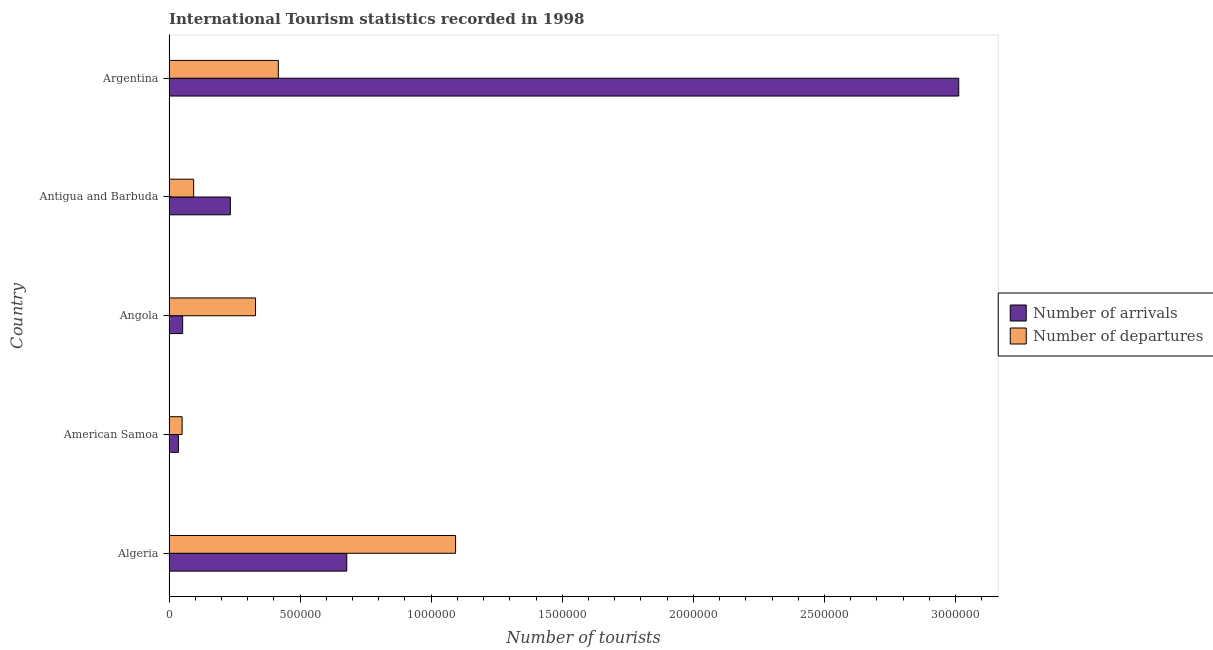How many groups of bars are there?
Offer a very short reply. 5. How many bars are there on the 4th tick from the top?
Offer a very short reply. 2. What is the label of the 4th group of bars from the top?
Provide a succinct answer. American Samoa. What is the number of tourist arrivals in Algeria?
Make the answer very short. 6.78e+05. Across all countries, what is the maximum number of tourist departures?
Your response must be concise. 1.09e+06. Across all countries, what is the minimum number of tourist arrivals?
Ensure brevity in your answer.  3.60e+04. In which country was the number of tourist departures maximum?
Your response must be concise. Algeria. In which country was the number of tourist departures minimum?
Your answer should be compact. American Samoa. What is the total number of tourist arrivals in the graph?
Ensure brevity in your answer.  4.01e+06. What is the difference between the number of tourist arrivals in American Samoa and that in Angola?
Provide a succinct answer. -1.60e+04. What is the difference between the number of tourist departures in Antigua and Barbuda and the number of tourist arrivals in Algeria?
Provide a succinct answer. -5.84e+05. What is the average number of tourist departures per country?
Ensure brevity in your answer.  3.97e+05. What is the difference between the number of tourist arrivals and number of tourist departures in Argentina?
Your answer should be very brief. 2.60e+06. In how many countries, is the number of tourist arrivals greater than 100000 ?
Provide a short and direct response. 3. What is the ratio of the number of tourist departures in Angola to that in Antigua and Barbuda?
Offer a very short reply. 3.51. Is the difference between the number of tourist arrivals in Algeria and American Samoa greater than the difference between the number of tourist departures in Algeria and American Samoa?
Provide a succinct answer. No. What is the difference between the highest and the second highest number of tourist departures?
Make the answer very short. 6.76e+05. What is the difference between the highest and the lowest number of tourist arrivals?
Give a very brief answer. 2.98e+06. What does the 2nd bar from the top in Argentina represents?
Ensure brevity in your answer.  Number of arrivals. What does the 1st bar from the bottom in Argentina represents?
Offer a terse response. Number of arrivals. How many bars are there?
Your response must be concise. 10. What is the difference between two consecutive major ticks on the X-axis?
Your response must be concise. 5.00e+05. Does the graph contain any zero values?
Keep it short and to the point. No. What is the title of the graph?
Give a very brief answer. International Tourism statistics recorded in 1998. Does "Secondary" appear as one of the legend labels in the graph?
Your response must be concise. No. What is the label or title of the X-axis?
Provide a short and direct response. Number of tourists. What is the label or title of the Y-axis?
Your response must be concise. Country. What is the Number of tourists of Number of arrivals in Algeria?
Provide a succinct answer. 6.78e+05. What is the Number of tourists in Number of departures in Algeria?
Offer a very short reply. 1.09e+06. What is the Number of tourists in Number of arrivals in American Samoa?
Your answer should be compact. 3.60e+04. What is the Number of tourists of Number of departures in American Samoa?
Ensure brevity in your answer.  5.00e+04. What is the Number of tourists of Number of arrivals in Angola?
Keep it short and to the point. 5.20e+04. What is the Number of tourists in Number of arrivals in Antigua and Barbuda?
Offer a very short reply. 2.34e+05. What is the Number of tourists in Number of departures in Antigua and Barbuda?
Provide a short and direct response. 9.40e+04. What is the Number of tourists in Number of arrivals in Argentina?
Make the answer very short. 3.01e+06. What is the Number of tourists in Number of departures in Argentina?
Your response must be concise. 4.17e+05. Across all countries, what is the maximum Number of tourists of Number of arrivals?
Provide a succinct answer. 3.01e+06. Across all countries, what is the maximum Number of tourists of Number of departures?
Offer a very short reply. 1.09e+06. Across all countries, what is the minimum Number of tourists of Number of arrivals?
Give a very brief answer. 3.60e+04. What is the total Number of tourists in Number of arrivals in the graph?
Provide a succinct answer. 4.01e+06. What is the total Number of tourists of Number of departures in the graph?
Offer a very short reply. 1.98e+06. What is the difference between the Number of tourists of Number of arrivals in Algeria and that in American Samoa?
Your answer should be very brief. 6.42e+05. What is the difference between the Number of tourists in Number of departures in Algeria and that in American Samoa?
Your answer should be very brief. 1.04e+06. What is the difference between the Number of tourists in Number of arrivals in Algeria and that in Angola?
Make the answer very short. 6.26e+05. What is the difference between the Number of tourists of Number of departures in Algeria and that in Angola?
Keep it short and to the point. 7.63e+05. What is the difference between the Number of tourists in Number of arrivals in Algeria and that in Antigua and Barbuda?
Make the answer very short. 4.44e+05. What is the difference between the Number of tourists in Number of departures in Algeria and that in Antigua and Barbuda?
Offer a terse response. 9.99e+05. What is the difference between the Number of tourists in Number of arrivals in Algeria and that in Argentina?
Your answer should be compact. -2.33e+06. What is the difference between the Number of tourists in Number of departures in Algeria and that in Argentina?
Ensure brevity in your answer.  6.76e+05. What is the difference between the Number of tourists of Number of arrivals in American Samoa and that in Angola?
Your answer should be compact. -1.60e+04. What is the difference between the Number of tourists of Number of departures in American Samoa and that in Angola?
Your answer should be very brief. -2.80e+05. What is the difference between the Number of tourists of Number of arrivals in American Samoa and that in Antigua and Barbuda?
Keep it short and to the point. -1.98e+05. What is the difference between the Number of tourists of Number of departures in American Samoa and that in Antigua and Barbuda?
Make the answer very short. -4.40e+04. What is the difference between the Number of tourists of Number of arrivals in American Samoa and that in Argentina?
Ensure brevity in your answer.  -2.98e+06. What is the difference between the Number of tourists of Number of departures in American Samoa and that in Argentina?
Provide a short and direct response. -3.67e+05. What is the difference between the Number of tourists of Number of arrivals in Angola and that in Antigua and Barbuda?
Offer a terse response. -1.82e+05. What is the difference between the Number of tourists of Number of departures in Angola and that in Antigua and Barbuda?
Provide a succinct answer. 2.36e+05. What is the difference between the Number of tourists in Number of arrivals in Angola and that in Argentina?
Keep it short and to the point. -2.96e+06. What is the difference between the Number of tourists in Number of departures in Angola and that in Argentina?
Make the answer very short. -8.70e+04. What is the difference between the Number of tourists of Number of arrivals in Antigua and Barbuda and that in Argentina?
Give a very brief answer. -2.78e+06. What is the difference between the Number of tourists in Number of departures in Antigua and Barbuda and that in Argentina?
Make the answer very short. -3.23e+05. What is the difference between the Number of tourists of Number of arrivals in Algeria and the Number of tourists of Number of departures in American Samoa?
Your answer should be very brief. 6.28e+05. What is the difference between the Number of tourists of Number of arrivals in Algeria and the Number of tourists of Number of departures in Angola?
Offer a terse response. 3.48e+05. What is the difference between the Number of tourists in Number of arrivals in Algeria and the Number of tourists in Number of departures in Antigua and Barbuda?
Make the answer very short. 5.84e+05. What is the difference between the Number of tourists of Number of arrivals in Algeria and the Number of tourists of Number of departures in Argentina?
Offer a terse response. 2.61e+05. What is the difference between the Number of tourists in Number of arrivals in American Samoa and the Number of tourists in Number of departures in Angola?
Offer a terse response. -2.94e+05. What is the difference between the Number of tourists in Number of arrivals in American Samoa and the Number of tourists in Number of departures in Antigua and Barbuda?
Ensure brevity in your answer.  -5.80e+04. What is the difference between the Number of tourists of Number of arrivals in American Samoa and the Number of tourists of Number of departures in Argentina?
Your answer should be very brief. -3.81e+05. What is the difference between the Number of tourists of Number of arrivals in Angola and the Number of tourists of Number of departures in Antigua and Barbuda?
Ensure brevity in your answer.  -4.20e+04. What is the difference between the Number of tourists in Number of arrivals in Angola and the Number of tourists in Number of departures in Argentina?
Keep it short and to the point. -3.65e+05. What is the difference between the Number of tourists of Number of arrivals in Antigua and Barbuda and the Number of tourists of Number of departures in Argentina?
Make the answer very short. -1.83e+05. What is the average Number of tourists of Number of arrivals per country?
Provide a short and direct response. 8.02e+05. What is the average Number of tourists in Number of departures per country?
Make the answer very short. 3.97e+05. What is the difference between the Number of tourists of Number of arrivals and Number of tourists of Number of departures in Algeria?
Your answer should be very brief. -4.15e+05. What is the difference between the Number of tourists in Number of arrivals and Number of tourists in Number of departures in American Samoa?
Your answer should be compact. -1.40e+04. What is the difference between the Number of tourists of Number of arrivals and Number of tourists of Number of departures in Angola?
Ensure brevity in your answer.  -2.78e+05. What is the difference between the Number of tourists in Number of arrivals and Number of tourists in Number of departures in Antigua and Barbuda?
Make the answer very short. 1.40e+05. What is the difference between the Number of tourists in Number of arrivals and Number of tourists in Number of departures in Argentina?
Ensure brevity in your answer.  2.60e+06. What is the ratio of the Number of tourists of Number of arrivals in Algeria to that in American Samoa?
Your response must be concise. 18.83. What is the ratio of the Number of tourists of Number of departures in Algeria to that in American Samoa?
Your answer should be compact. 21.86. What is the ratio of the Number of tourists in Number of arrivals in Algeria to that in Angola?
Make the answer very short. 13.04. What is the ratio of the Number of tourists of Number of departures in Algeria to that in Angola?
Make the answer very short. 3.31. What is the ratio of the Number of tourists in Number of arrivals in Algeria to that in Antigua and Barbuda?
Your answer should be compact. 2.9. What is the ratio of the Number of tourists in Number of departures in Algeria to that in Antigua and Barbuda?
Your response must be concise. 11.63. What is the ratio of the Number of tourists of Number of arrivals in Algeria to that in Argentina?
Your response must be concise. 0.23. What is the ratio of the Number of tourists in Number of departures in Algeria to that in Argentina?
Provide a short and direct response. 2.62. What is the ratio of the Number of tourists of Number of arrivals in American Samoa to that in Angola?
Make the answer very short. 0.69. What is the ratio of the Number of tourists in Number of departures in American Samoa to that in Angola?
Give a very brief answer. 0.15. What is the ratio of the Number of tourists in Number of arrivals in American Samoa to that in Antigua and Barbuda?
Offer a very short reply. 0.15. What is the ratio of the Number of tourists in Number of departures in American Samoa to that in Antigua and Barbuda?
Offer a very short reply. 0.53. What is the ratio of the Number of tourists of Number of arrivals in American Samoa to that in Argentina?
Your answer should be compact. 0.01. What is the ratio of the Number of tourists of Number of departures in American Samoa to that in Argentina?
Provide a succinct answer. 0.12. What is the ratio of the Number of tourists of Number of arrivals in Angola to that in Antigua and Barbuda?
Give a very brief answer. 0.22. What is the ratio of the Number of tourists of Number of departures in Angola to that in Antigua and Barbuda?
Ensure brevity in your answer.  3.51. What is the ratio of the Number of tourists of Number of arrivals in Angola to that in Argentina?
Offer a very short reply. 0.02. What is the ratio of the Number of tourists of Number of departures in Angola to that in Argentina?
Provide a short and direct response. 0.79. What is the ratio of the Number of tourists of Number of arrivals in Antigua and Barbuda to that in Argentina?
Keep it short and to the point. 0.08. What is the ratio of the Number of tourists in Number of departures in Antigua and Barbuda to that in Argentina?
Give a very brief answer. 0.23. What is the difference between the highest and the second highest Number of tourists of Number of arrivals?
Offer a very short reply. 2.33e+06. What is the difference between the highest and the second highest Number of tourists in Number of departures?
Provide a succinct answer. 6.76e+05. What is the difference between the highest and the lowest Number of tourists in Number of arrivals?
Make the answer very short. 2.98e+06. What is the difference between the highest and the lowest Number of tourists in Number of departures?
Offer a terse response. 1.04e+06. 